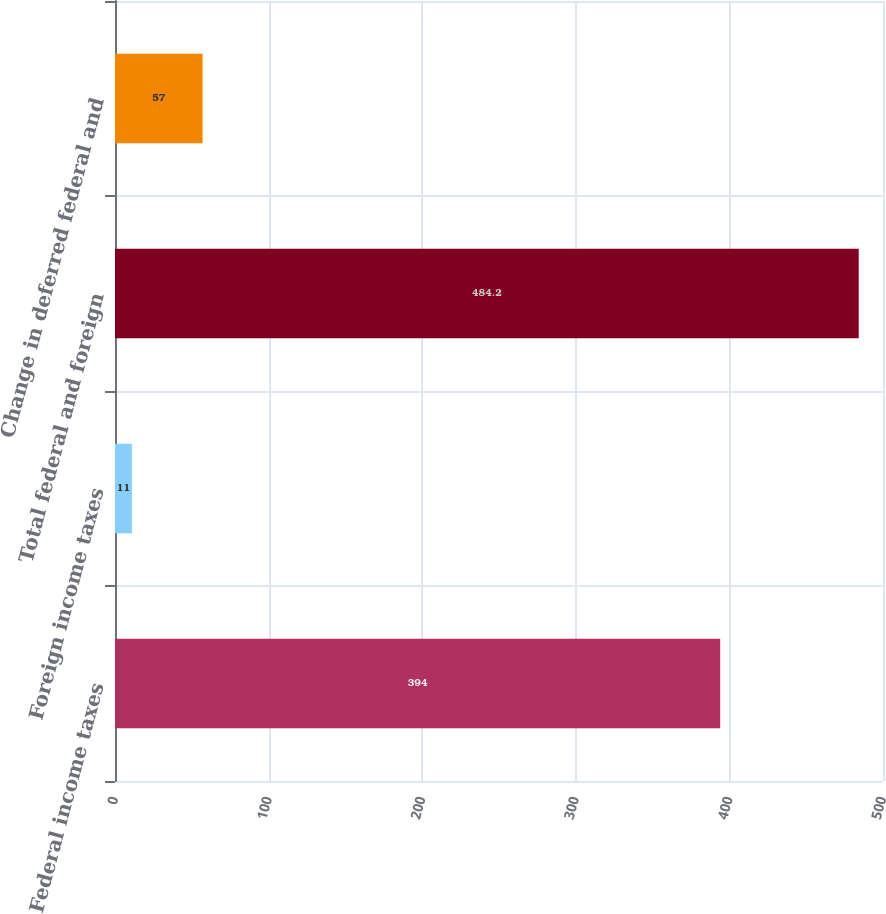Convert chart. <chart><loc_0><loc_0><loc_500><loc_500><bar_chart><fcel>Federal income taxes<fcel>Foreign income taxes<fcel>Total federal and foreign<fcel>Change in deferred federal and<nl><fcel>394<fcel>11<fcel>484.2<fcel>57<nl></chart> 